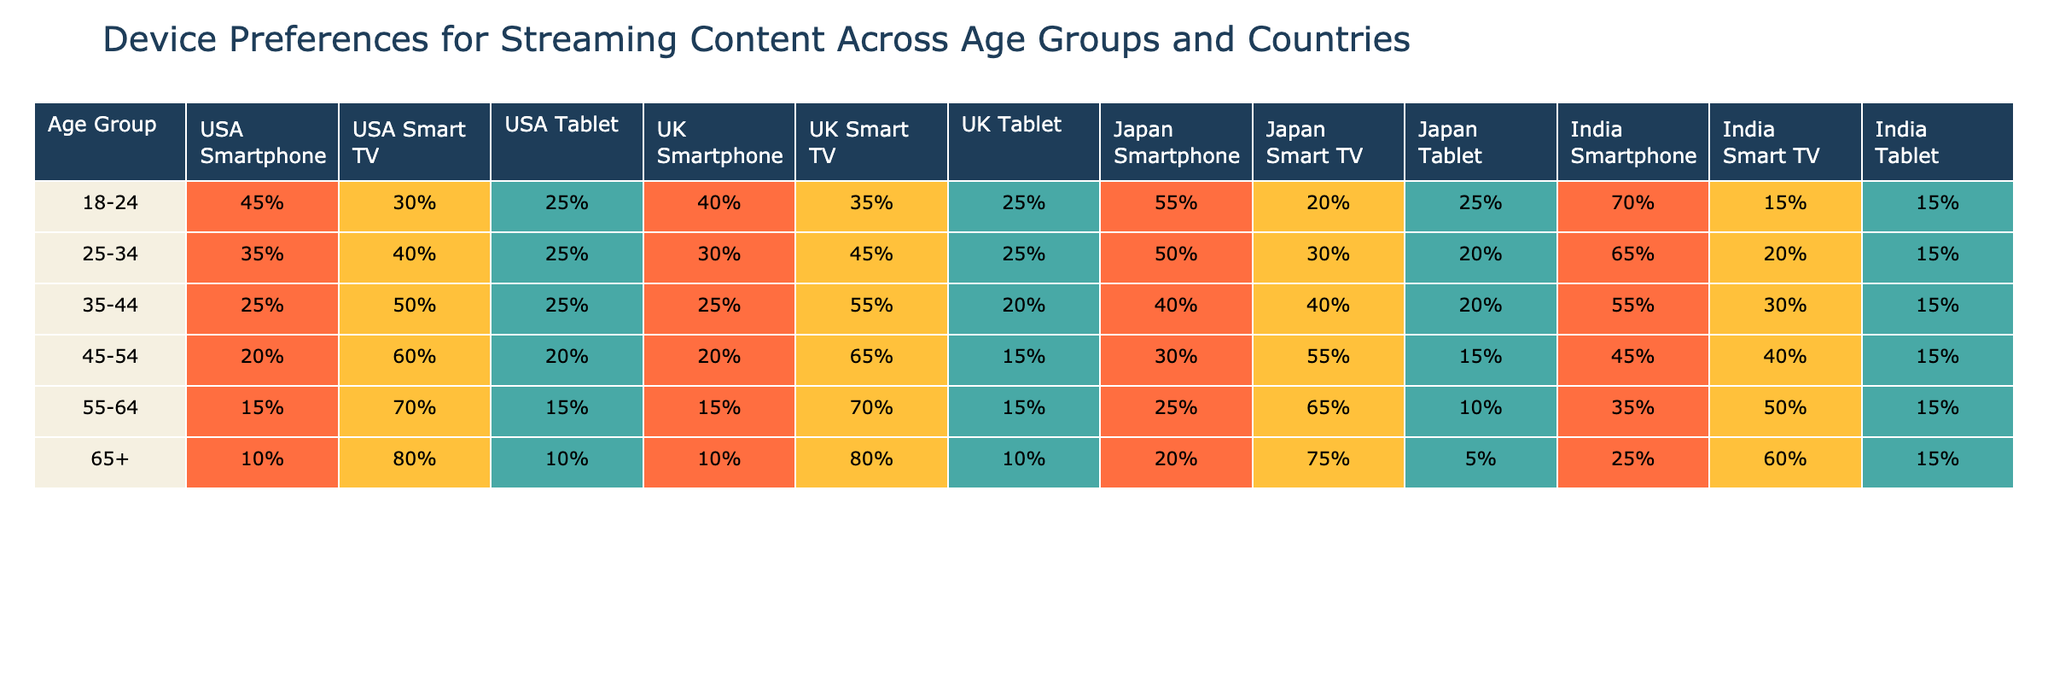What percentage of 18-24 year-olds in the USA prefer watching on Smart TVs? According to the table, 30% of 18-24 year-olds in the USA prefer Smart TVs for streaming content.
Answer: 30% Which device do the majority of 65+ year-olds in Japan prefer for streaming? In Japan, 75% of the 65+ age group prefer Smart TVs for streaming.
Answer: Smart TV How does the preference for tablets compare between 25-34 year-olds in the USA and India? In the USA, 25% of the 25-34 age group prefer tablets, while in India, it's 15%. The difference is 10% more in the USA.
Answer: USA prefers tablets 10% more Is it true that more than half of 45-54 year-olds in the UK prefer Smart TVs? The table shows that 65% of 45-54 year-olds in the UK prefer Smart TVs, which is indeed more than half.
Answer: Yes What is the total percentage of smartphone usage for streaming among 35-44 year-olds across all countries? For 35-44 year-olds, the percentages are: USA 25% + UK 25% + Japan 40% + India 20% = 110%. The total percentage is 110%.
Answer: 110% Among all age groups, which country has the highest preference for using smartphones to watch content? Looking across all age groups, India shows the highest preference with 70% in the 18-24 age group for smartphones.
Answer: India (70% in age 18-24) What is the average preference for tablets among all age groups in the USA? The percentages for tablets in the USA across age groups are: 25% (18-24) + 25% (25-34) + 20% (35-44) + 20% (45-54) + 15% (55-64) + 10% (65+) = 125%. Dividing by 6 gives an average of about 20.83%.
Answer: 20.83% Which age group shows the least preference for smartphones in the USA? The 65+ age group has the least preference for smartphones in the USA, with only 10%.
Answer: 65+ age group (10%) In which country do 55-64 year-olds prefer Smart TVs the most for streaming? In the UK, 70% of the 55-64 age group prefer Smart TVs for streaming, which is the highest percentage in this age group among the countries listed.
Answer: UK (70%) 